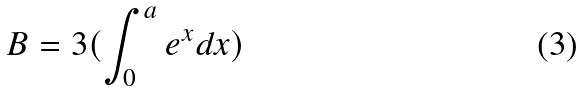<formula> <loc_0><loc_0><loc_500><loc_500>B = 3 ( \int _ { 0 } ^ { a } e ^ { x } d x )</formula> 